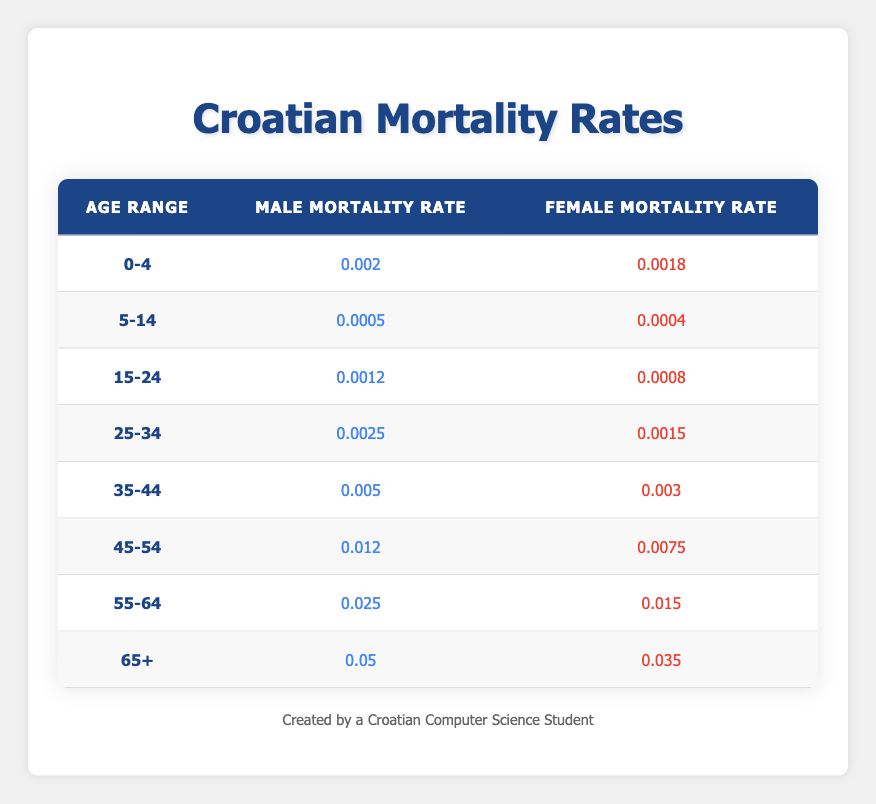What is the female mortality rate for the age group 15-24? Looking at the "15-24" age range in the table, the female mortality rate corresponds to the value listed under the "Female Mortality Rate" column, which is 0.0008.
Answer: 0.0008 What is the male mortality rate for the age group 35-44? From the "35-44" age range row, the male mortality rate found in the "Male Mortality Rate" column is 0.005.
Answer: 0.005 What is the difference between the male and female mortality rates in the 45-54 age group? The male mortality rate for the 45-54 age range is 0.012 and the female mortality rate is 0.0075. To find the difference, subtract the female rate from the male rate: 0.012 - 0.0075 = 0.0045.
Answer: 0.0045 Is the male mortality rate higher in the age group 25-34 than in 15-24? Checking the rates, the male mortality rate for 25-34 is 0.0025 and for 15-24 is 0.0012. Since 0.0025 is greater than 0.0012, the statement is true.
Answer: Yes What is the average male mortality rate across all age groups? To find the average, sum all male mortality rates (0.002 + 0.0005 + 0.0012 + 0.0025 + 0.005 + 0.012 + 0.025 + 0.05 = 0.0982) and divide by the number of age groups (8). So, 0.0982 / 8 = 0.012275.
Answer: 0.012275 In which age group is the female mortality rate the highest? Looking at the female mortality rates across all age groups, the highest value is 0.035 in the "65+" age group.
Answer: 65+ What is the combined male mortality rate for the ages 0-14? For the age groups 0-4 and 5-14, the male mortality rates are 0.002 and 0.0005, respectively. Adding these together gives 0.002 + 0.0005 = 0.0025.
Answer: 0.0025 Is the male mortality rate for the age group 55-64 greater than the female mortality rate for the same group? The male mortality rate for 55-64 is 0.025, while the female rate is 0.015. Since 0.025 is greater than 0.015, the answer is affirmative.
Answer: Yes What is the total mortality rate for females aged 45-64? The female mortality rates for the groups 45-54 (0.0075) and 55-64 (0.015) need to be summed: 0.0075 + 0.015 = 0.0225.
Answer: 0.0225 